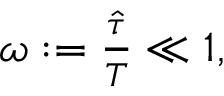<formula> <loc_0><loc_0><loc_500><loc_500>\begin{array} { r } { \omega \colon = \frac { \hat { \tau } } { T } \ll 1 , } \end{array}</formula> 